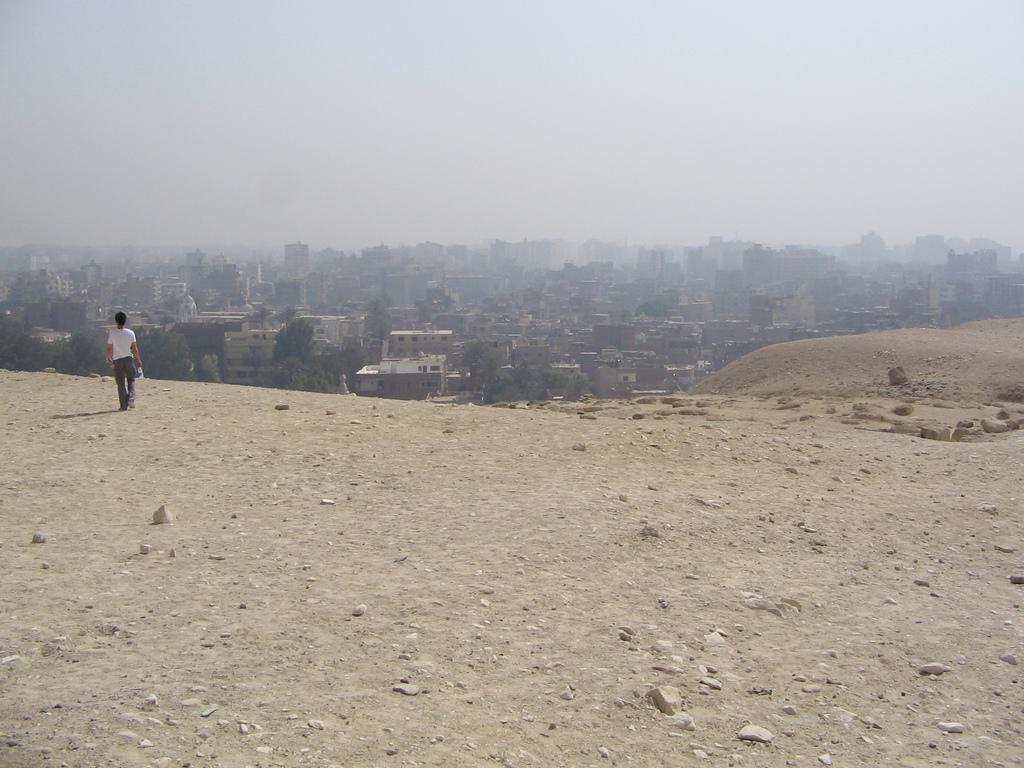How would you summarize this image in a sentence or two? In the background of the image there are buildings, sky. At the bottom of the image there is ground. There is a person walking. 